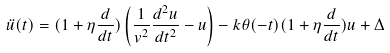<formula> <loc_0><loc_0><loc_500><loc_500>\ddot { u } ( t ) = ( 1 + \eta \frac { d } { d t } ) \left ( \frac { 1 } { v ^ { 2 } } \frac { d ^ { 2 } u } { d t ^ { 2 } } - u \right ) - k \theta ( - t ) ( 1 + \eta \frac { d } { d t } ) u + \Delta</formula> 